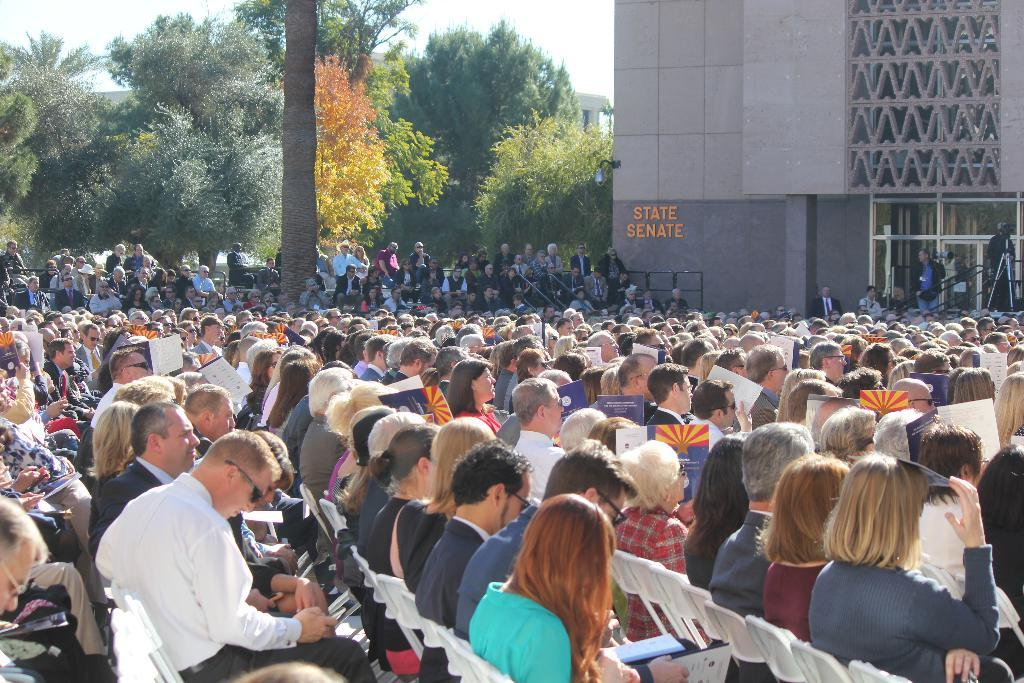What are the people in the image doing? There are many people sitting on chairs in the image. What can be seen in the background of the image? There are trees visible in the background of the image. Can you identify the building in the image? Yes, there is a building with a name in the image. What object is used for capturing images in the image? There is a camera in the image. Can you tell me how many giraffes are standing next to the building in the image? There are no giraffes present in the image; it features people sitting on chairs, trees in the background, a named building, and a camera. 